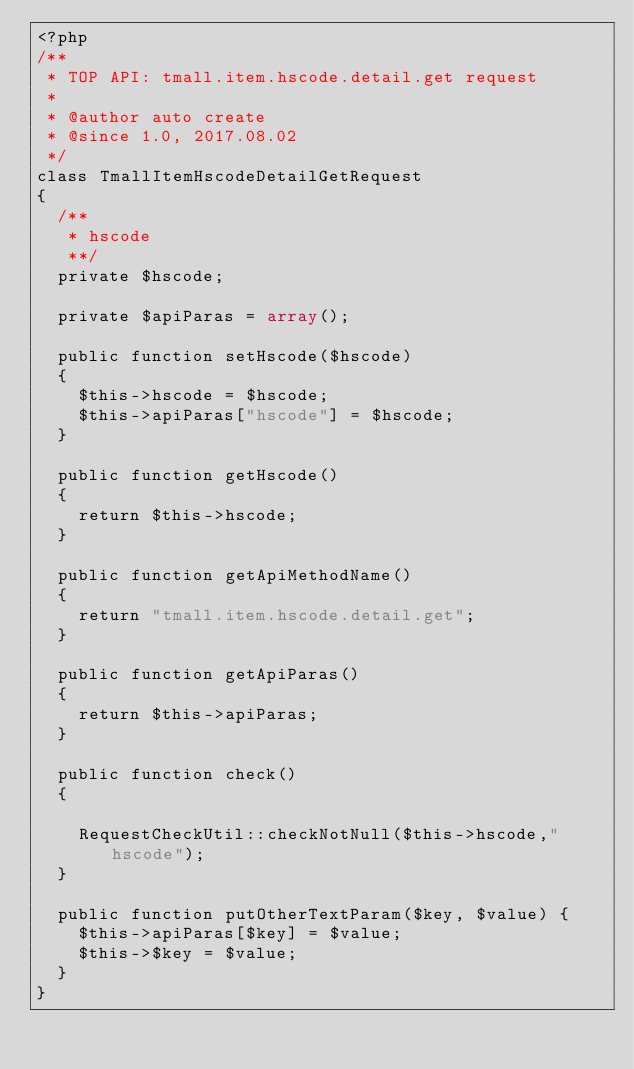Convert code to text. <code><loc_0><loc_0><loc_500><loc_500><_PHP_><?php
/**
 * TOP API: tmall.item.hscode.detail.get request
 * 
 * @author auto create
 * @since 1.0, 2017.08.02
 */
class TmallItemHscodeDetailGetRequest
{
	/** 
	 * hscode
	 **/
	private $hscode;
	
	private $apiParas = array();
	
	public function setHscode($hscode)
	{
		$this->hscode = $hscode;
		$this->apiParas["hscode"] = $hscode;
	}

	public function getHscode()
	{
		return $this->hscode;
	}

	public function getApiMethodName()
	{
		return "tmall.item.hscode.detail.get";
	}
	
	public function getApiParas()
	{
		return $this->apiParas;
	}
	
	public function check()
	{
		
		RequestCheckUtil::checkNotNull($this->hscode,"hscode");
	}
	
	public function putOtherTextParam($key, $value) {
		$this->apiParas[$key] = $value;
		$this->$key = $value;
	}
}
</code> 